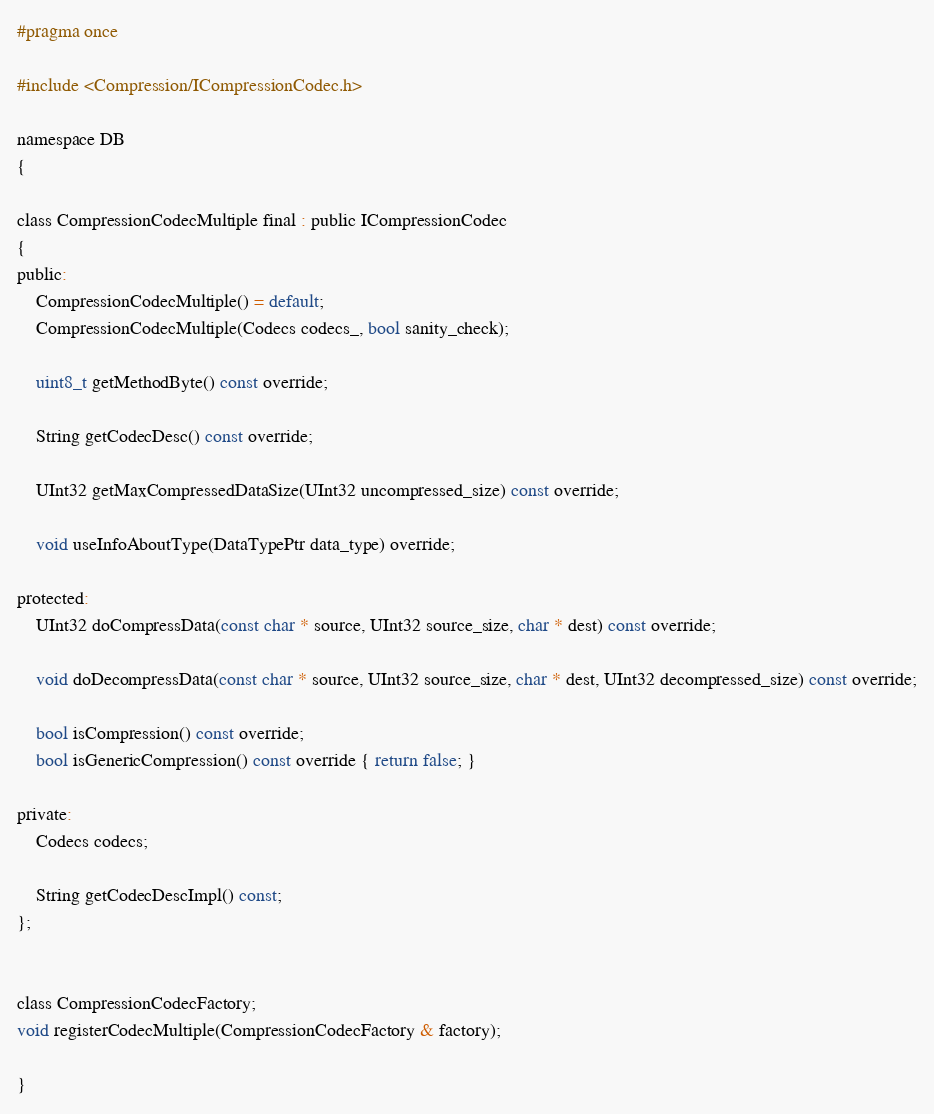Convert code to text. <code><loc_0><loc_0><loc_500><loc_500><_C_>#pragma once

#include <Compression/ICompressionCodec.h>

namespace DB
{

class CompressionCodecMultiple final : public ICompressionCodec
{
public:
    CompressionCodecMultiple() = default;
    CompressionCodecMultiple(Codecs codecs_, bool sanity_check);

    uint8_t getMethodByte() const override;

    String getCodecDesc() const override;

    UInt32 getMaxCompressedDataSize(UInt32 uncompressed_size) const override;

    void useInfoAboutType(DataTypePtr data_type) override;

protected:
    UInt32 doCompressData(const char * source, UInt32 source_size, char * dest) const override;

    void doDecompressData(const char * source, UInt32 source_size, char * dest, UInt32 decompressed_size) const override;

    bool isCompression() const override;
    bool isGenericCompression() const override { return false; }

private:
    Codecs codecs;

    String getCodecDescImpl() const;
};


class CompressionCodecFactory;
void registerCodecMultiple(CompressionCodecFactory & factory);

}
</code> 